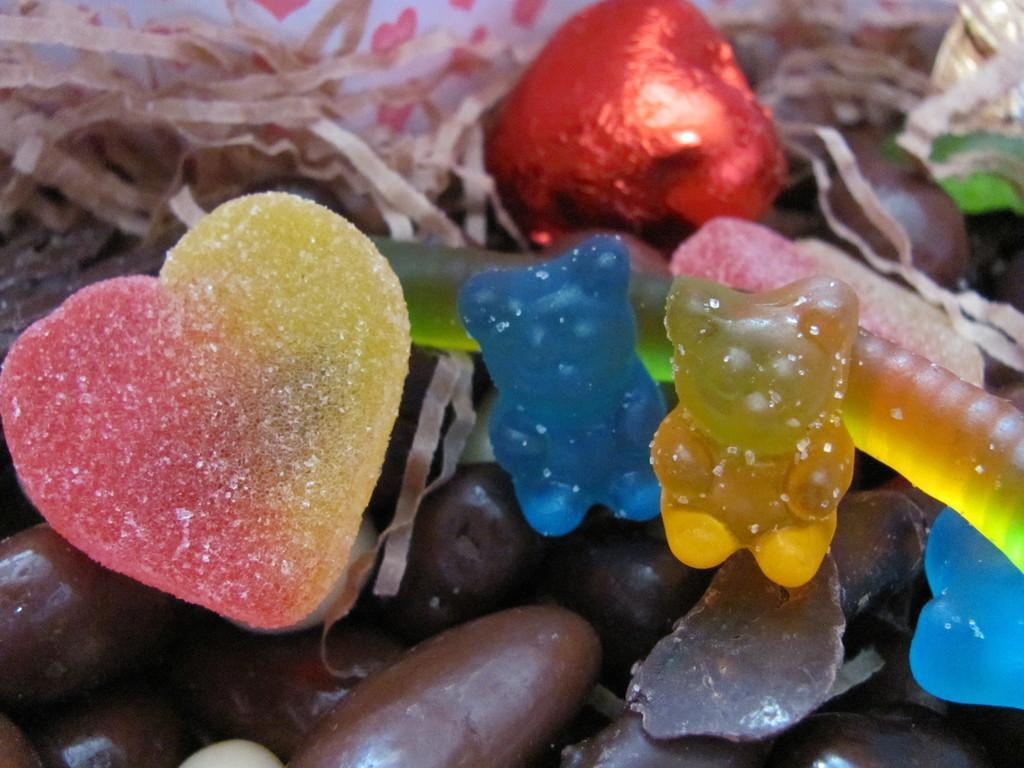Can you describe this image briefly? In this picture, there are different colors of candies and chocolates. 